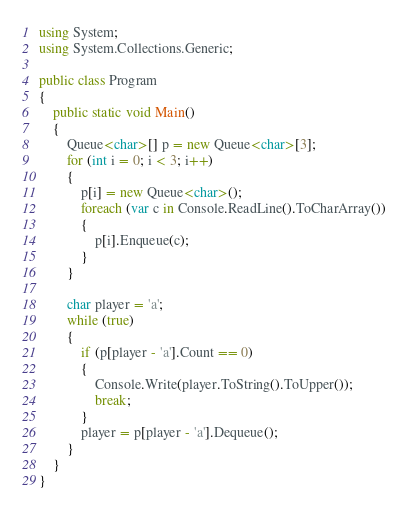Convert code to text. <code><loc_0><loc_0><loc_500><loc_500><_C#_>using System;
using System.Collections.Generic;

public class Program
{
    public static void Main()
    {
        Queue<char>[] p = new Queue<char>[3];
        for (int i = 0; i < 3; i++)
        {
            p[i] = new Queue<char>();
            foreach (var c in Console.ReadLine().ToCharArray())
            {
                p[i].Enqueue(c);
            }
        }

        char player = 'a';
        while (true)
        {
            if (p[player - 'a'].Count == 0)
            {
                Console.Write(player.ToString().ToUpper());
                break;
            }
            player = p[player - 'a'].Dequeue();
        }
    }
}
</code> 